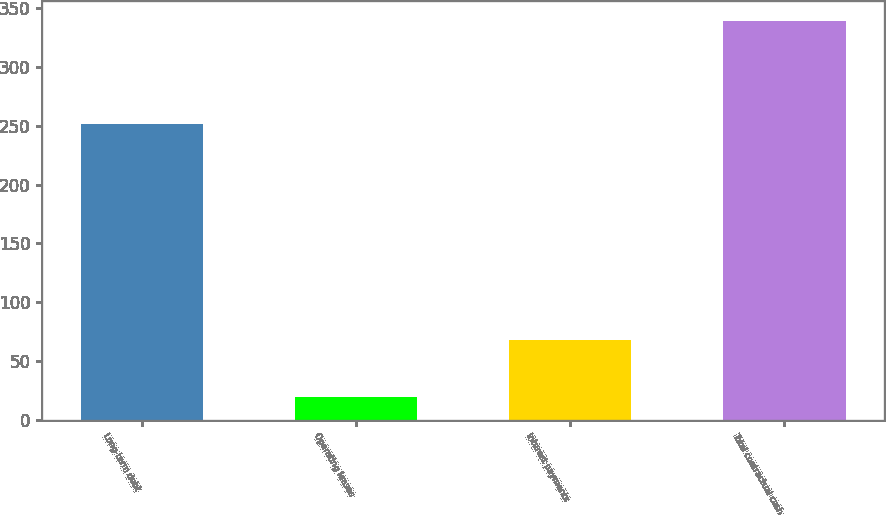Convert chart. <chart><loc_0><loc_0><loc_500><loc_500><bar_chart><fcel>Long-term debt<fcel>Operating leases<fcel>Interest payments<fcel>Total contractual cash<nl><fcel>251.9<fcel>19.5<fcel>67.9<fcel>339.3<nl></chart> 